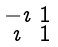<formula> <loc_0><loc_0><loc_500><loc_500>\begin{smallmatrix} - \imath & 1 \\ \imath & 1 \end{smallmatrix}</formula> 